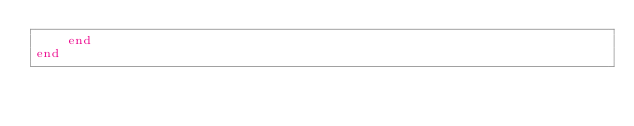Convert code to text. <code><loc_0><loc_0><loc_500><loc_500><_Julia_>    end
end
</code> 